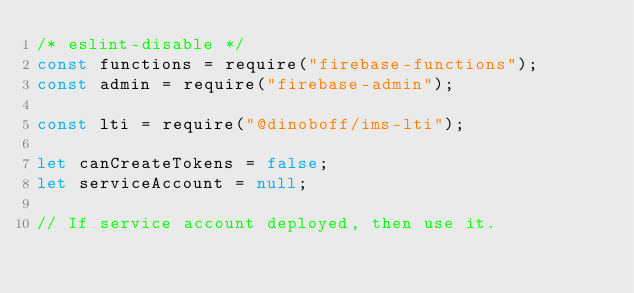Convert code to text. <code><loc_0><loc_0><loc_500><loc_500><_JavaScript_>/* eslint-disable */
const functions = require("firebase-functions");
const admin = require("firebase-admin");

const lti = require("@dinoboff/ims-lti");

let canCreateTokens = false;
let serviceAccount = null;

// If service account deployed, then use it.</code> 